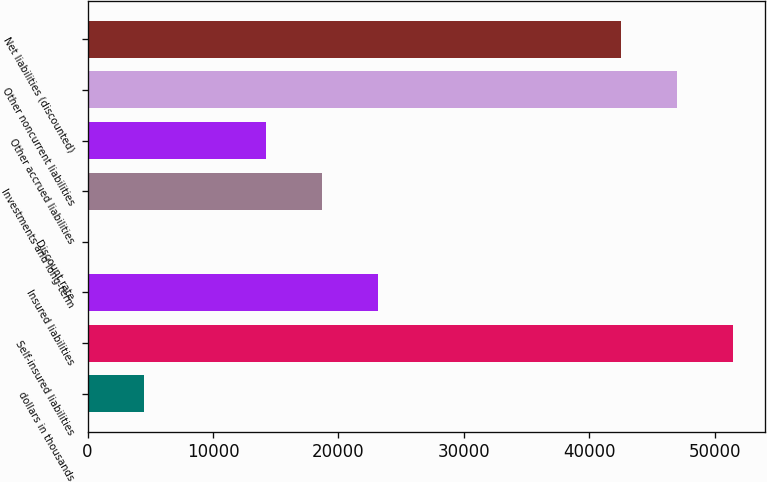Convert chart. <chart><loc_0><loc_0><loc_500><loc_500><bar_chart><fcel>dollars in thousands<fcel>Self-insured liabilities<fcel>Insured liabilities<fcel>Discount rate<fcel>Investments and long-term<fcel>Other accrued liabilities<fcel>Other noncurrent liabilities<fcel>Net liabilities (discounted)<nl><fcel>4463.1<fcel>51413.3<fcel>23121.3<fcel>1.44<fcel>18659.7<fcel>14198<fcel>46951.7<fcel>42490<nl></chart> 